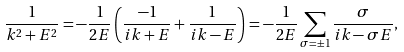Convert formula to latex. <formula><loc_0><loc_0><loc_500><loc_500>\frac { 1 } { k ^ { 2 } + E ^ { 2 } } = - \frac { 1 } { 2 E } \left ( \frac { - 1 } { i k + E } + \frac { 1 } { i k - E } \right ) = - \frac { 1 } { 2 E } \sum _ { \sigma = \pm 1 } \frac { \sigma } { i k - \sigma E } ,</formula> 